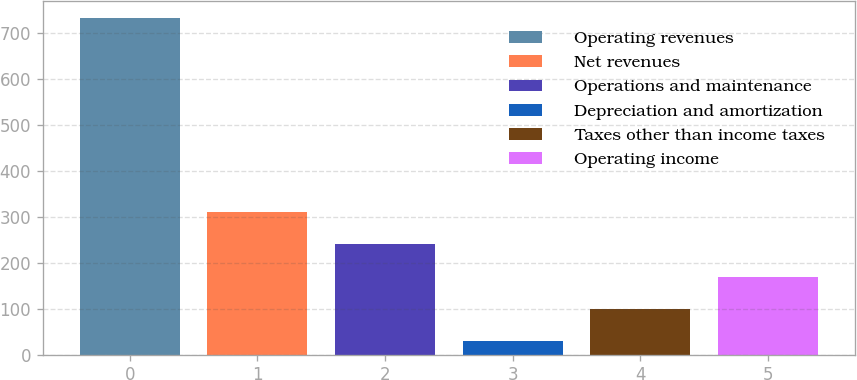Convert chart to OTSL. <chart><loc_0><loc_0><loc_500><loc_500><bar_chart><fcel>Operating revenues<fcel>Net revenues<fcel>Operations and maintenance<fcel>Depreciation and amortization<fcel>Taxes other than income taxes<fcel>Operating income<nl><fcel>733<fcel>310.6<fcel>240.2<fcel>29<fcel>99.4<fcel>169.8<nl></chart> 